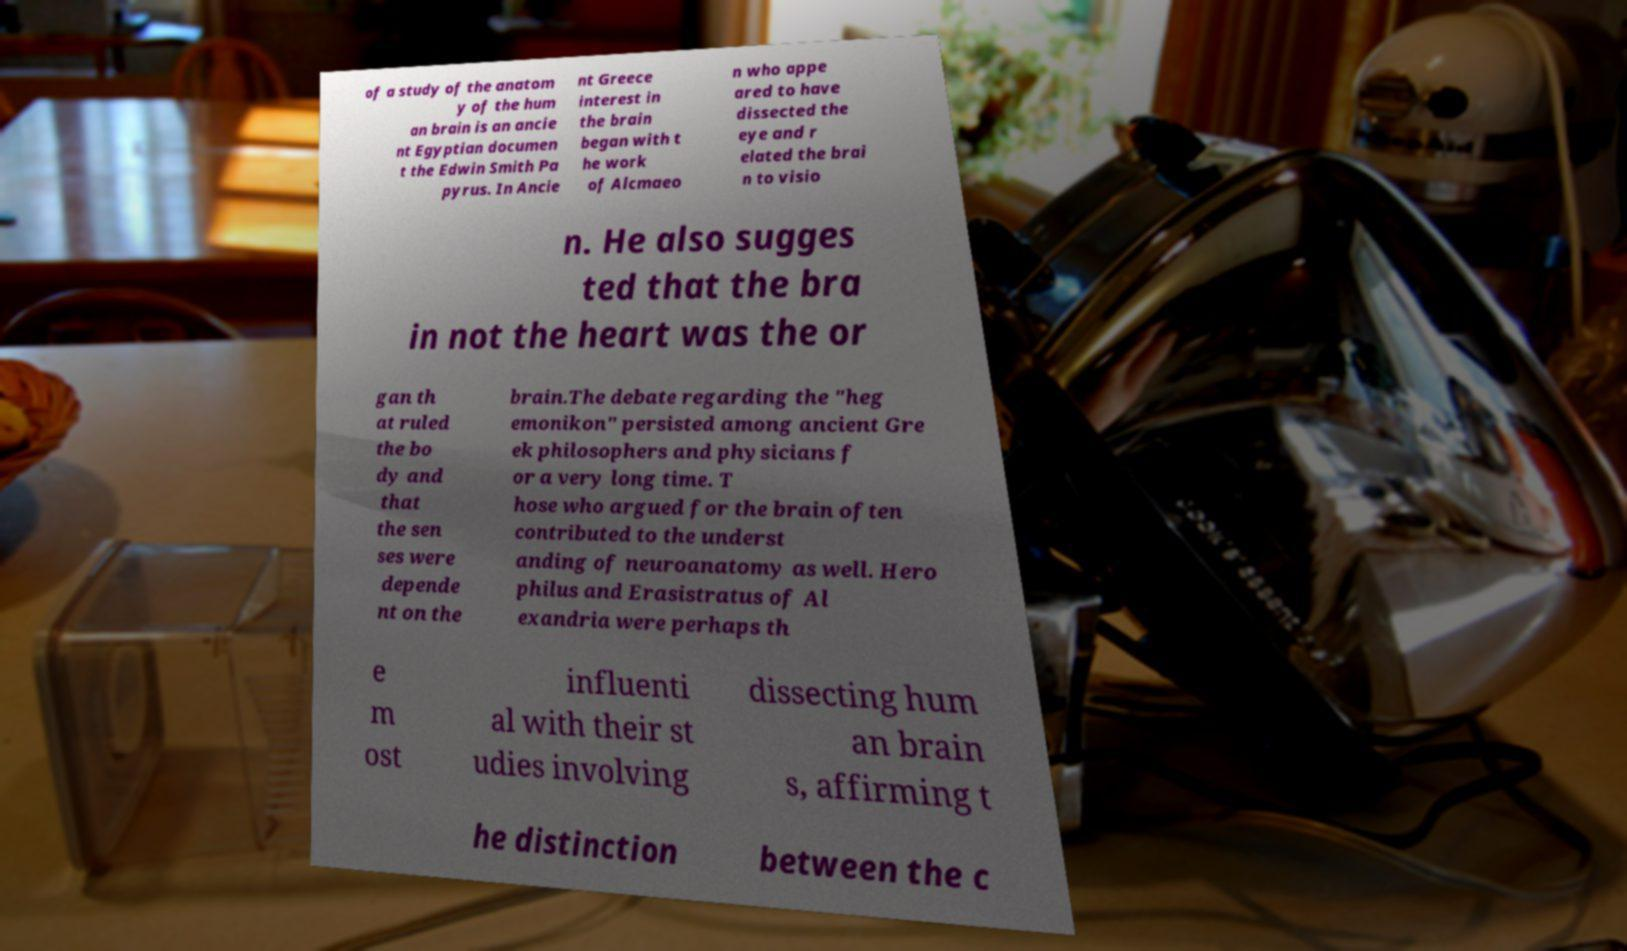For documentation purposes, I need the text within this image transcribed. Could you provide that? of a study of the anatom y of the hum an brain is an ancie nt Egyptian documen t the Edwin Smith Pa pyrus. In Ancie nt Greece interest in the brain began with t he work of Alcmaeo n who appe ared to have dissected the eye and r elated the brai n to visio n. He also sugges ted that the bra in not the heart was the or gan th at ruled the bo dy and that the sen ses were depende nt on the brain.The debate regarding the "heg emonikon" persisted among ancient Gre ek philosophers and physicians f or a very long time. T hose who argued for the brain often contributed to the underst anding of neuroanatomy as well. Hero philus and Erasistratus of Al exandria were perhaps th e m ost influenti al with their st udies involving dissecting hum an brain s, affirming t he distinction between the c 